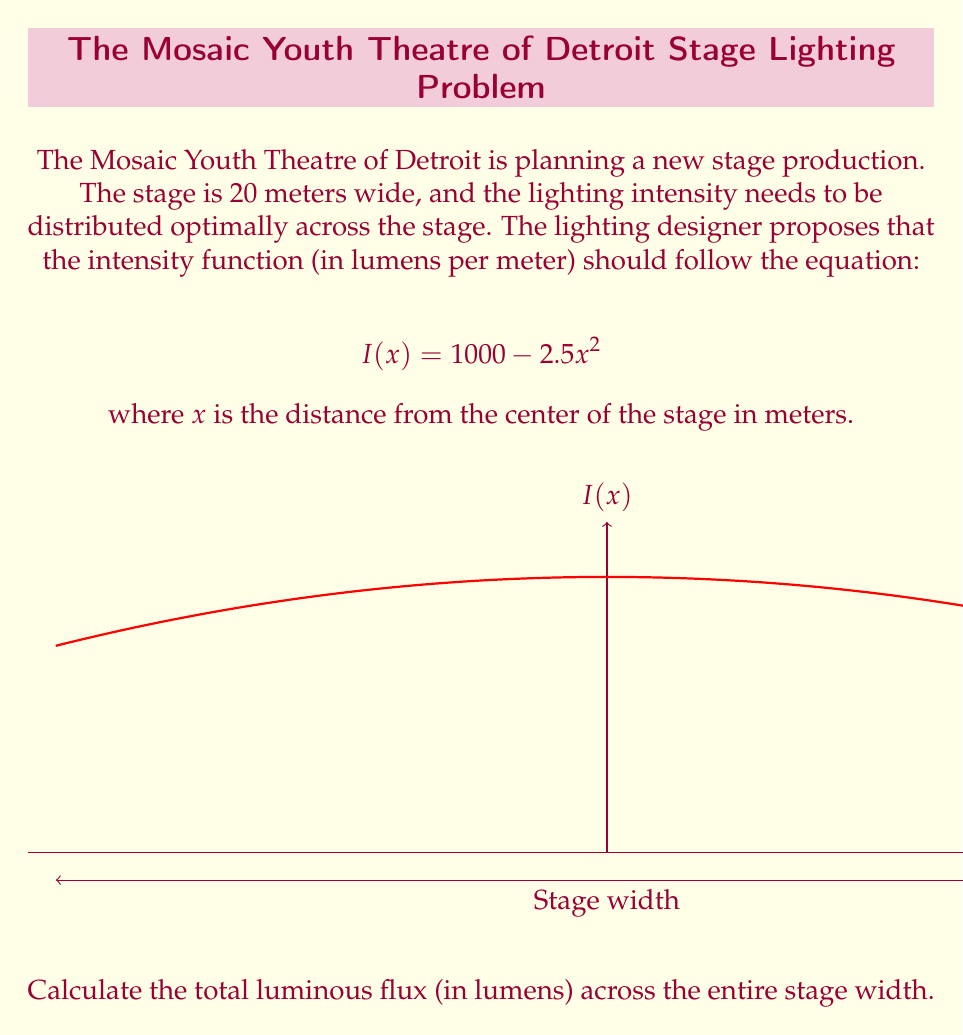Give your solution to this math problem. To solve this problem, we need to integrate the intensity function across the entire width of the stage. Let's break it down step-by-step:

1) The stage is 20 meters wide, so it extends from -10 meters to +10 meters from the center.

2) The total luminous flux is the integral of the intensity function over this range:

   $$\text{Total Flux} = \int_{-10}^{10} I(x) dx$$

3) Substituting the given intensity function:

   $$\text{Total Flux} = \int_{-10}^{10} (1000 - 2.5x^2) dx$$

4) We can split this into two integrals:

   $$\text{Total Flux} = \int_{-10}^{10} 1000 dx - \int_{-10}^{10} 2.5x^2 dx$$

5) Evaluating the first integral:

   $$\int_{-10}^{10} 1000 dx = 1000x \bigg|_{-10}^{10} = 1000(10 - (-10)) = 20000$$

6) For the second integral:

   $$\int_{-10}^{10} 2.5x^2 dx = 2.5 \cdot \frac{x^3}{3} \bigg|_{-10}^{10} = \frac{5}{3}(10^3 - (-10^3)) = \frac{5}{3} \cdot 2000 = \frac{10000}{3}$$

7) Combining the results:

   $$\text{Total Flux} = 20000 - \frac{10000}{3} = \frac{60000 - 10000}{3} = \frac{50000}{3}$$

Therefore, the total luminous flux across the entire stage width is $\frac{50000}{3}$ lumens.
Answer: $\frac{50000}{3}$ lumens 